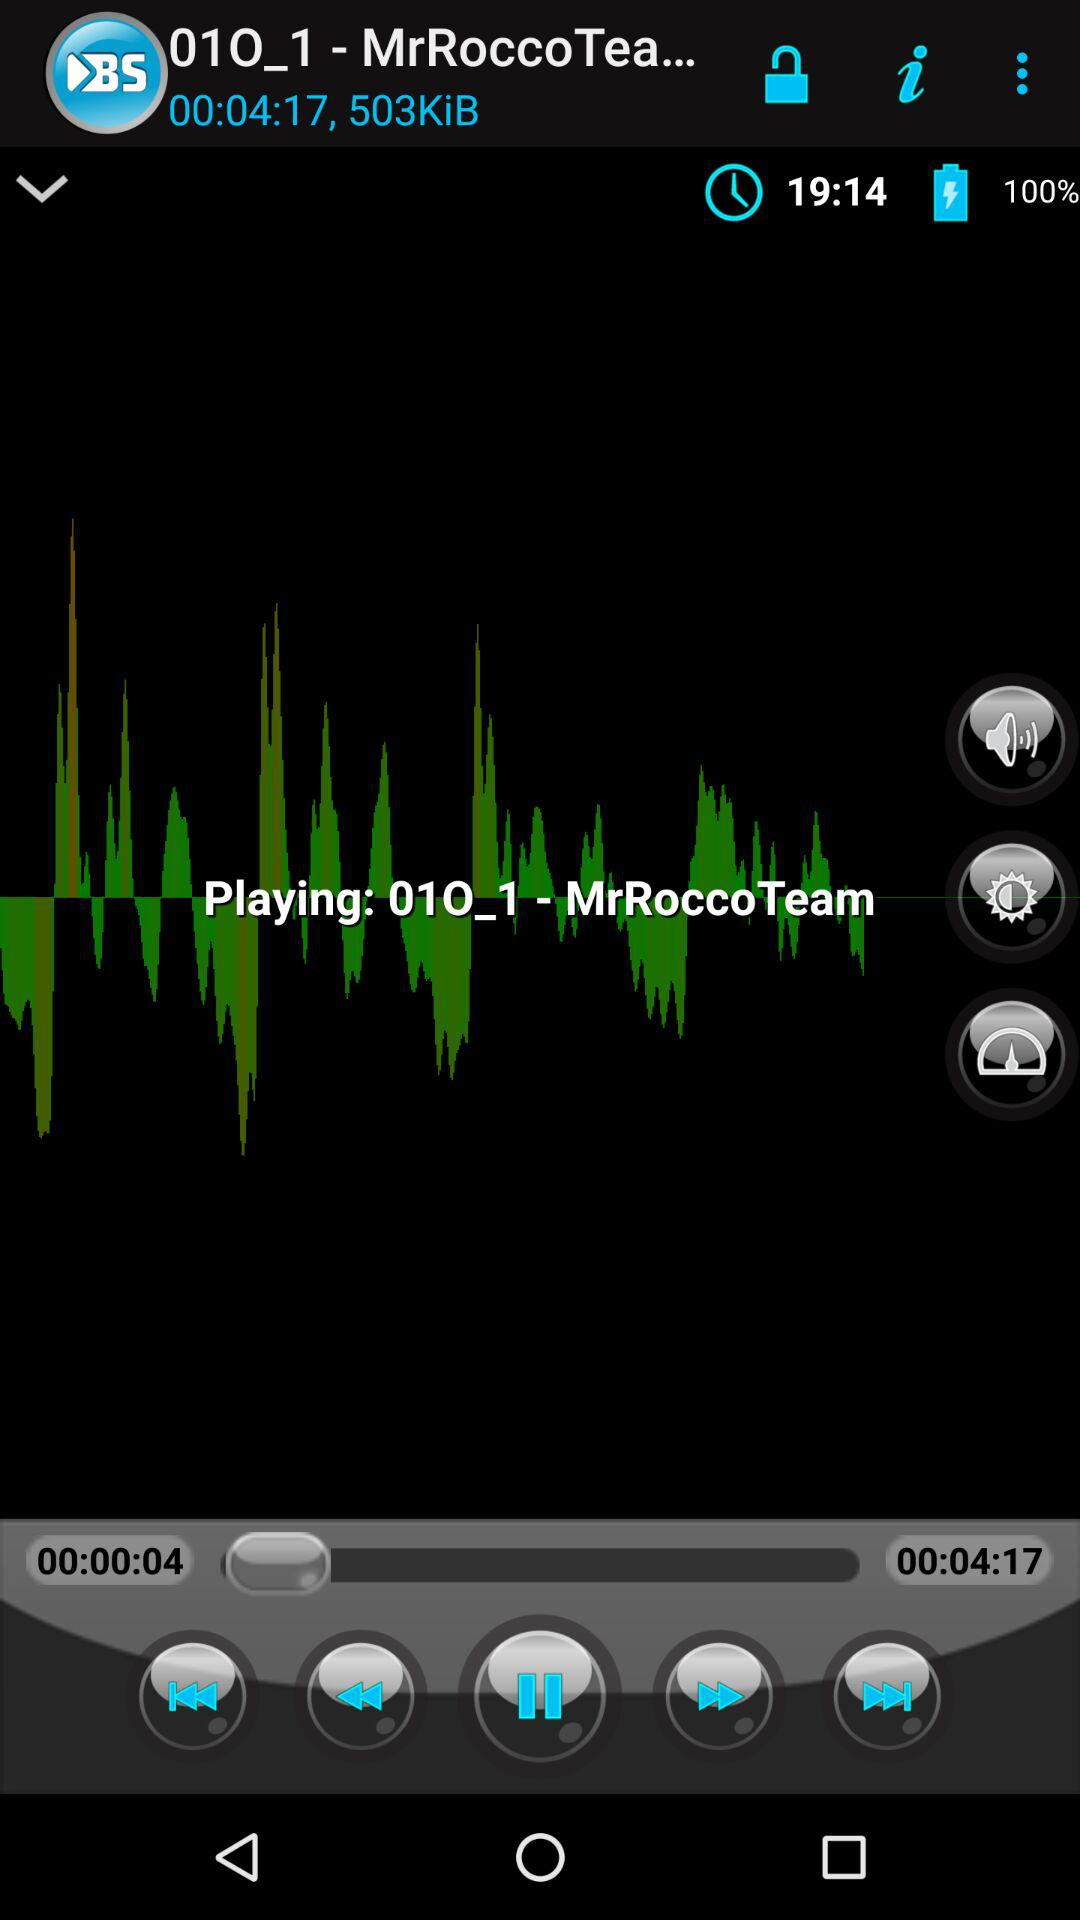What is the duration of the song? The duration of the song is 4 minutes and 17 seconds. 